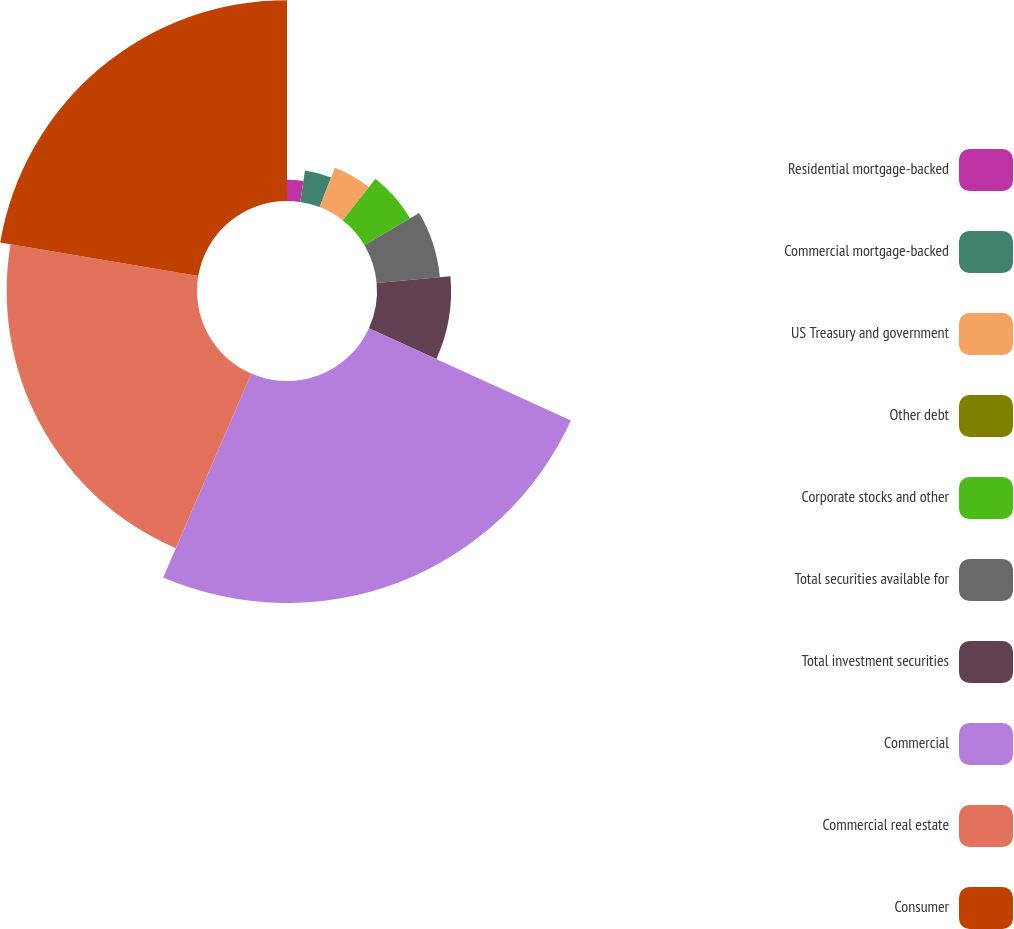Convert chart. <chart><loc_0><loc_0><loc_500><loc_500><pie_chart><fcel>Residential mortgage-backed<fcel>Commercial mortgage-backed<fcel>US Treasury and government<fcel>Other debt<fcel>Corporate stocks and other<fcel>Total securities available for<fcel>Total investment securities<fcel>Commercial<fcel>Commercial real estate<fcel>Consumer<nl><fcel>2.36%<fcel>3.54%<fcel>4.71%<fcel>0.01%<fcel>5.89%<fcel>7.06%<fcel>8.24%<fcel>24.69%<fcel>21.17%<fcel>22.34%<nl></chart> 